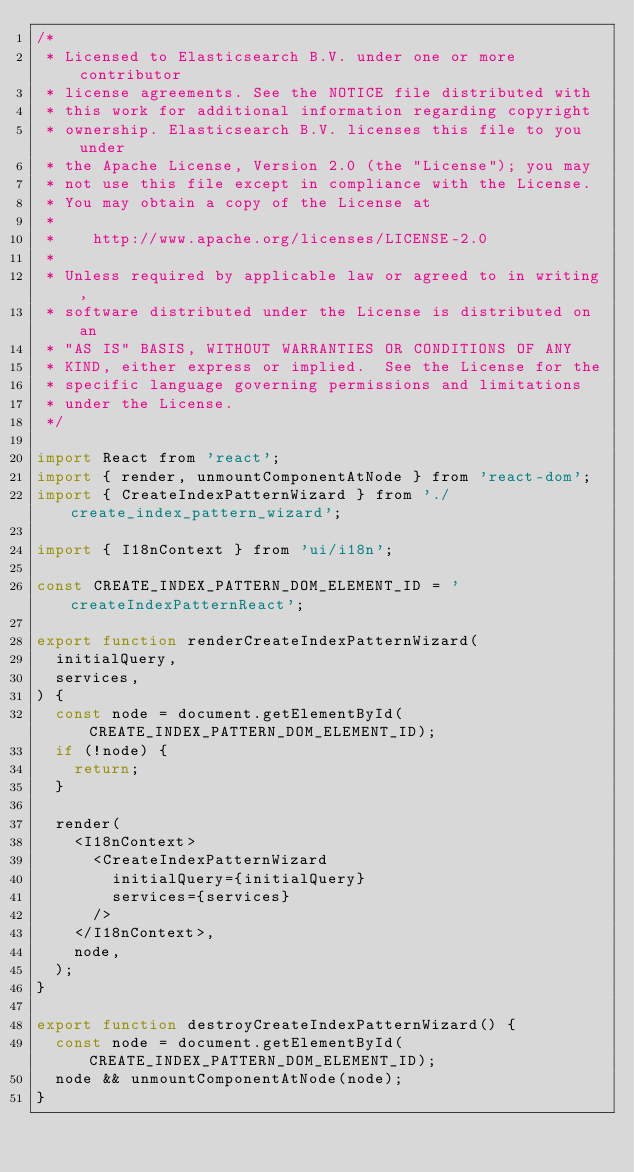<code> <loc_0><loc_0><loc_500><loc_500><_JavaScript_>/*
 * Licensed to Elasticsearch B.V. under one or more contributor
 * license agreements. See the NOTICE file distributed with
 * this work for additional information regarding copyright
 * ownership. Elasticsearch B.V. licenses this file to you under
 * the Apache License, Version 2.0 (the "License"); you may
 * not use this file except in compliance with the License.
 * You may obtain a copy of the License at
 *
 *    http://www.apache.org/licenses/LICENSE-2.0
 *
 * Unless required by applicable law or agreed to in writing,
 * software distributed under the License is distributed on an
 * "AS IS" BASIS, WITHOUT WARRANTIES OR CONDITIONS OF ANY
 * KIND, either express or implied.  See the License for the
 * specific language governing permissions and limitations
 * under the License.
 */

import React from 'react';
import { render, unmountComponentAtNode } from 'react-dom';
import { CreateIndexPatternWizard } from './create_index_pattern_wizard';

import { I18nContext } from 'ui/i18n';

const CREATE_INDEX_PATTERN_DOM_ELEMENT_ID = 'createIndexPatternReact';

export function renderCreateIndexPatternWizard(
  initialQuery,
  services,
) {
  const node = document.getElementById(CREATE_INDEX_PATTERN_DOM_ELEMENT_ID);
  if (!node) {
    return;
  }

  render(
    <I18nContext>
      <CreateIndexPatternWizard
        initialQuery={initialQuery}
        services={services}
      />
    </I18nContext>,
    node,
  );
}

export function destroyCreateIndexPatternWizard() {
  const node = document.getElementById(CREATE_INDEX_PATTERN_DOM_ELEMENT_ID);
  node && unmountComponentAtNode(node);
}
</code> 